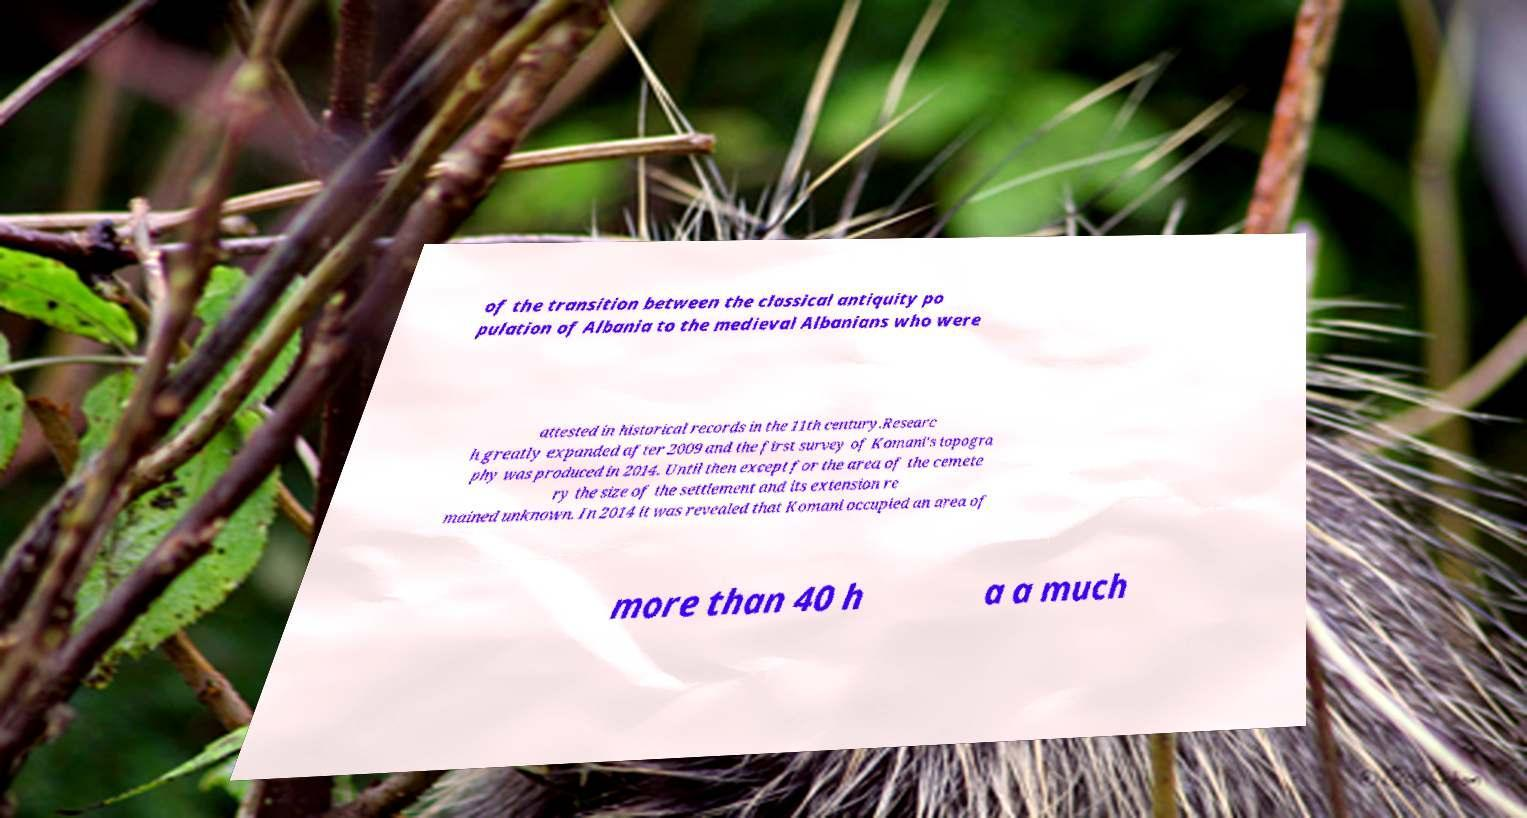Can you read and provide the text displayed in the image?This photo seems to have some interesting text. Can you extract and type it out for me? of the transition between the classical antiquity po pulation of Albania to the medieval Albanians who were attested in historical records in the 11th century.Researc h greatly expanded after 2009 and the first survey of Komani's topogra phy was produced in 2014. Until then except for the area of the cemete ry the size of the settlement and its extension re mained unknown. In 2014 it was revealed that Komani occupied an area of more than 40 h a a much 